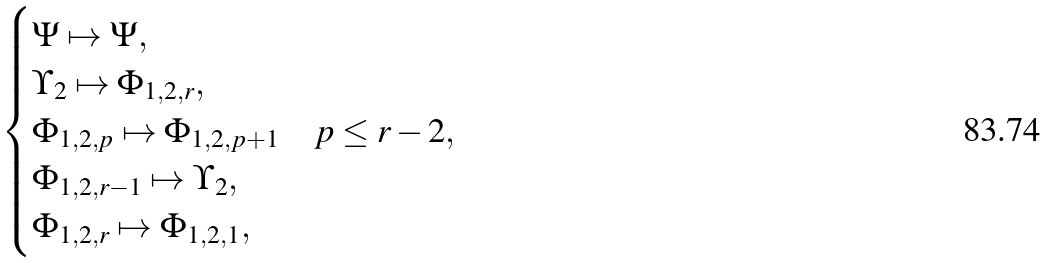Convert formula to latex. <formula><loc_0><loc_0><loc_500><loc_500>\begin{cases} \Psi \mapsto \Psi , \\ \Upsilon _ { 2 } \mapsto \Phi _ { 1 , 2 , r } , \\ \Phi _ { 1 , 2 , p } \mapsto \Phi _ { 1 , 2 , p + 1 } & p \leq r - 2 , \\ \Phi _ { 1 , 2 , r - 1 } \mapsto \Upsilon _ { 2 } , \\ \Phi _ { 1 , 2 , r } \mapsto \Phi _ { 1 , 2 , 1 } , \end{cases}</formula> 